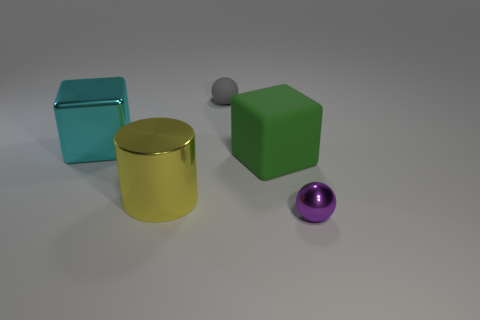There is a large metal cube; is it the same color as the big thing to the right of the yellow metal cylinder?
Give a very brief answer. No. What size is the green matte thing that is the same shape as the big cyan metallic object?
Offer a very short reply. Large. There is a object that is both right of the cyan object and behind the green rubber block; what is its shape?
Your answer should be compact. Sphere. Is the size of the gray thing the same as the shiny thing that is left of the large yellow cylinder?
Keep it short and to the point. No. The other metal object that is the same shape as the big green object is what color?
Make the answer very short. Cyan. Do the sphere behind the purple metal sphere and the cube that is to the right of the large cyan shiny block have the same size?
Provide a succinct answer. No. Is the shape of the large yellow thing the same as the tiny gray matte object?
Keep it short and to the point. No. What number of things are small objects that are right of the large rubber thing or tiny brown spheres?
Offer a terse response. 1. Is there another big object that has the same shape as the big green matte object?
Provide a short and direct response. Yes. Are there the same number of green objects in front of the big cyan thing and big cyan shiny spheres?
Your answer should be very brief. No. 